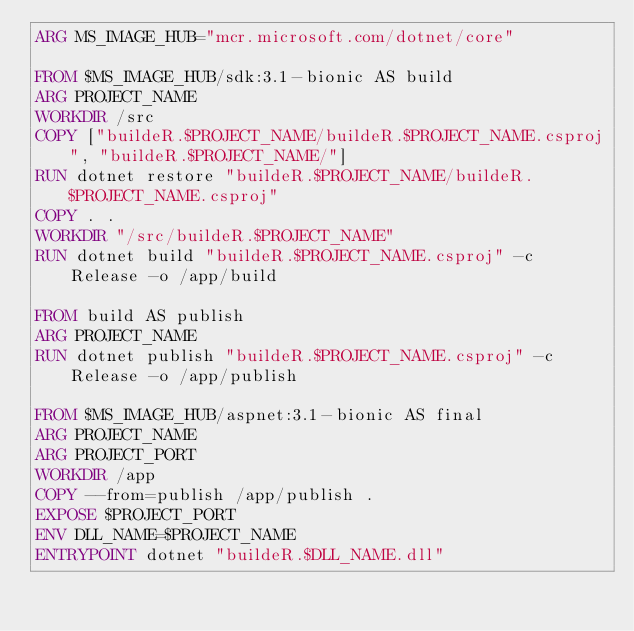<code> <loc_0><loc_0><loc_500><loc_500><_Dockerfile_>ARG MS_IMAGE_HUB="mcr.microsoft.com/dotnet/core"

FROM $MS_IMAGE_HUB/sdk:3.1-bionic AS build
ARG PROJECT_NAME
WORKDIR /src
COPY ["buildeR.$PROJECT_NAME/buildeR.$PROJECT_NAME.csproj", "buildeR.$PROJECT_NAME/"]
RUN dotnet restore "buildeR.$PROJECT_NAME/buildeR.$PROJECT_NAME.csproj"
COPY . .
WORKDIR "/src/buildeR.$PROJECT_NAME"
RUN dotnet build "buildeR.$PROJECT_NAME.csproj" -c Release -o /app/build

FROM build AS publish
ARG PROJECT_NAME
RUN dotnet publish "buildeR.$PROJECT_NAME.csproj" -c Release -o /app/publish

FROM $MS_IMAGE_HUB/aspnet:3.1-bionic AS final
ARG PROJECT_NAME
ARG PROJECT_PORT
WORKDIR /app
COPY --from=publish /app/publish .
EXPOSE $PROJECT_PORT
ENV DLL_NAME=$PROJECT_NAME
ENTRYPOINT dotnet "buildeR.$DLL_NAME.dll"</code> 